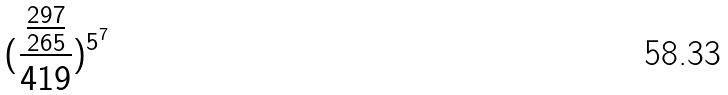Convert formula to latex. <formula><loc_0><loc_0><loc_500><loc_500>( \frac { \frac { 2 9 7 } { 2 6 5 } } { 4 1 9 } ) ^ { 5 ^ { 7 } }</formula> 